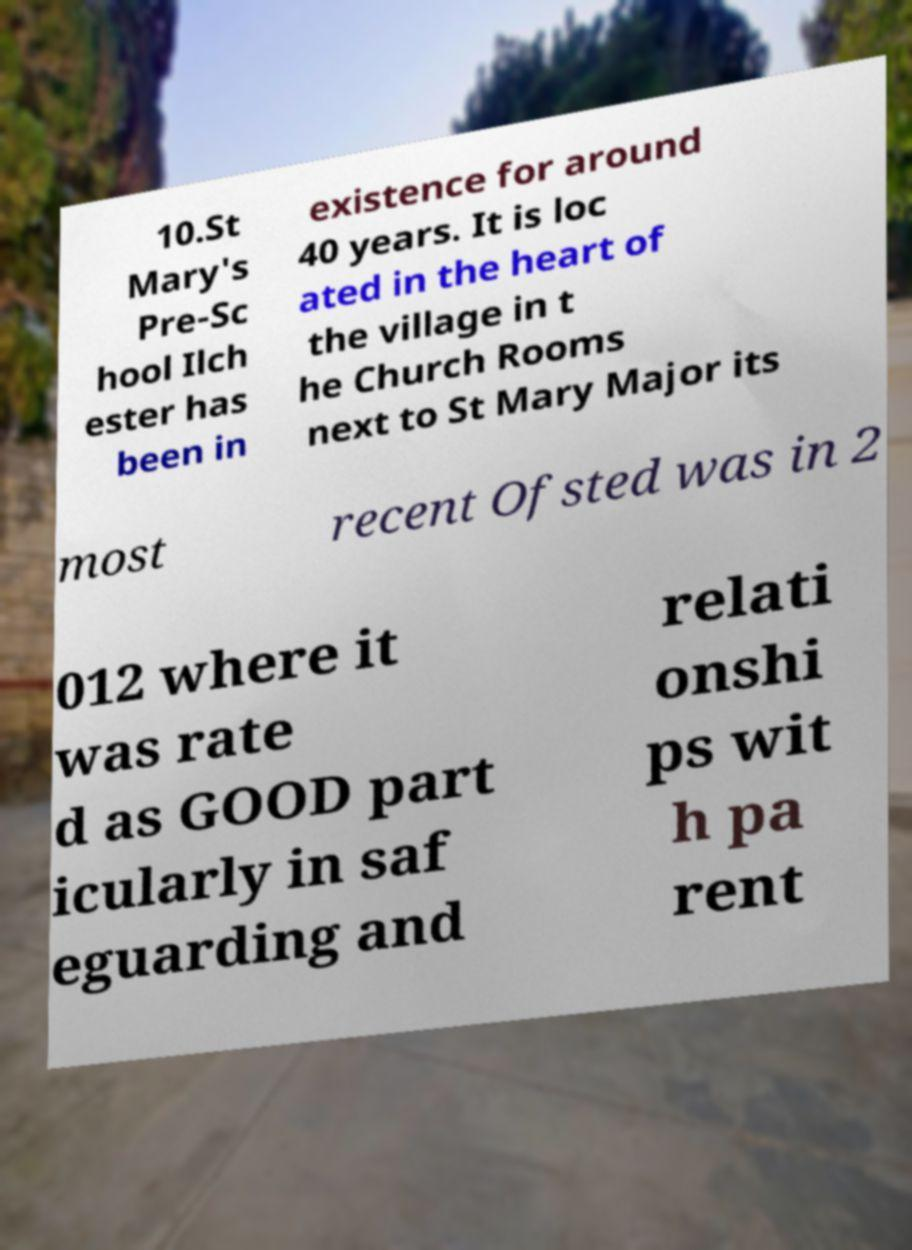Can you accurately transcribe the text from the provided image for me? 10.St Mary's Pre-Sc hool Ilch ester has been in existence for around 40 years. It is loc ated in the heart of the village in t he Church Rooms next to St Mary Major its most recent Ofsted was in 2 012 where it was rate d as GOOD part icularly in saf eguarding and relati onshi ps wit h pa rent 